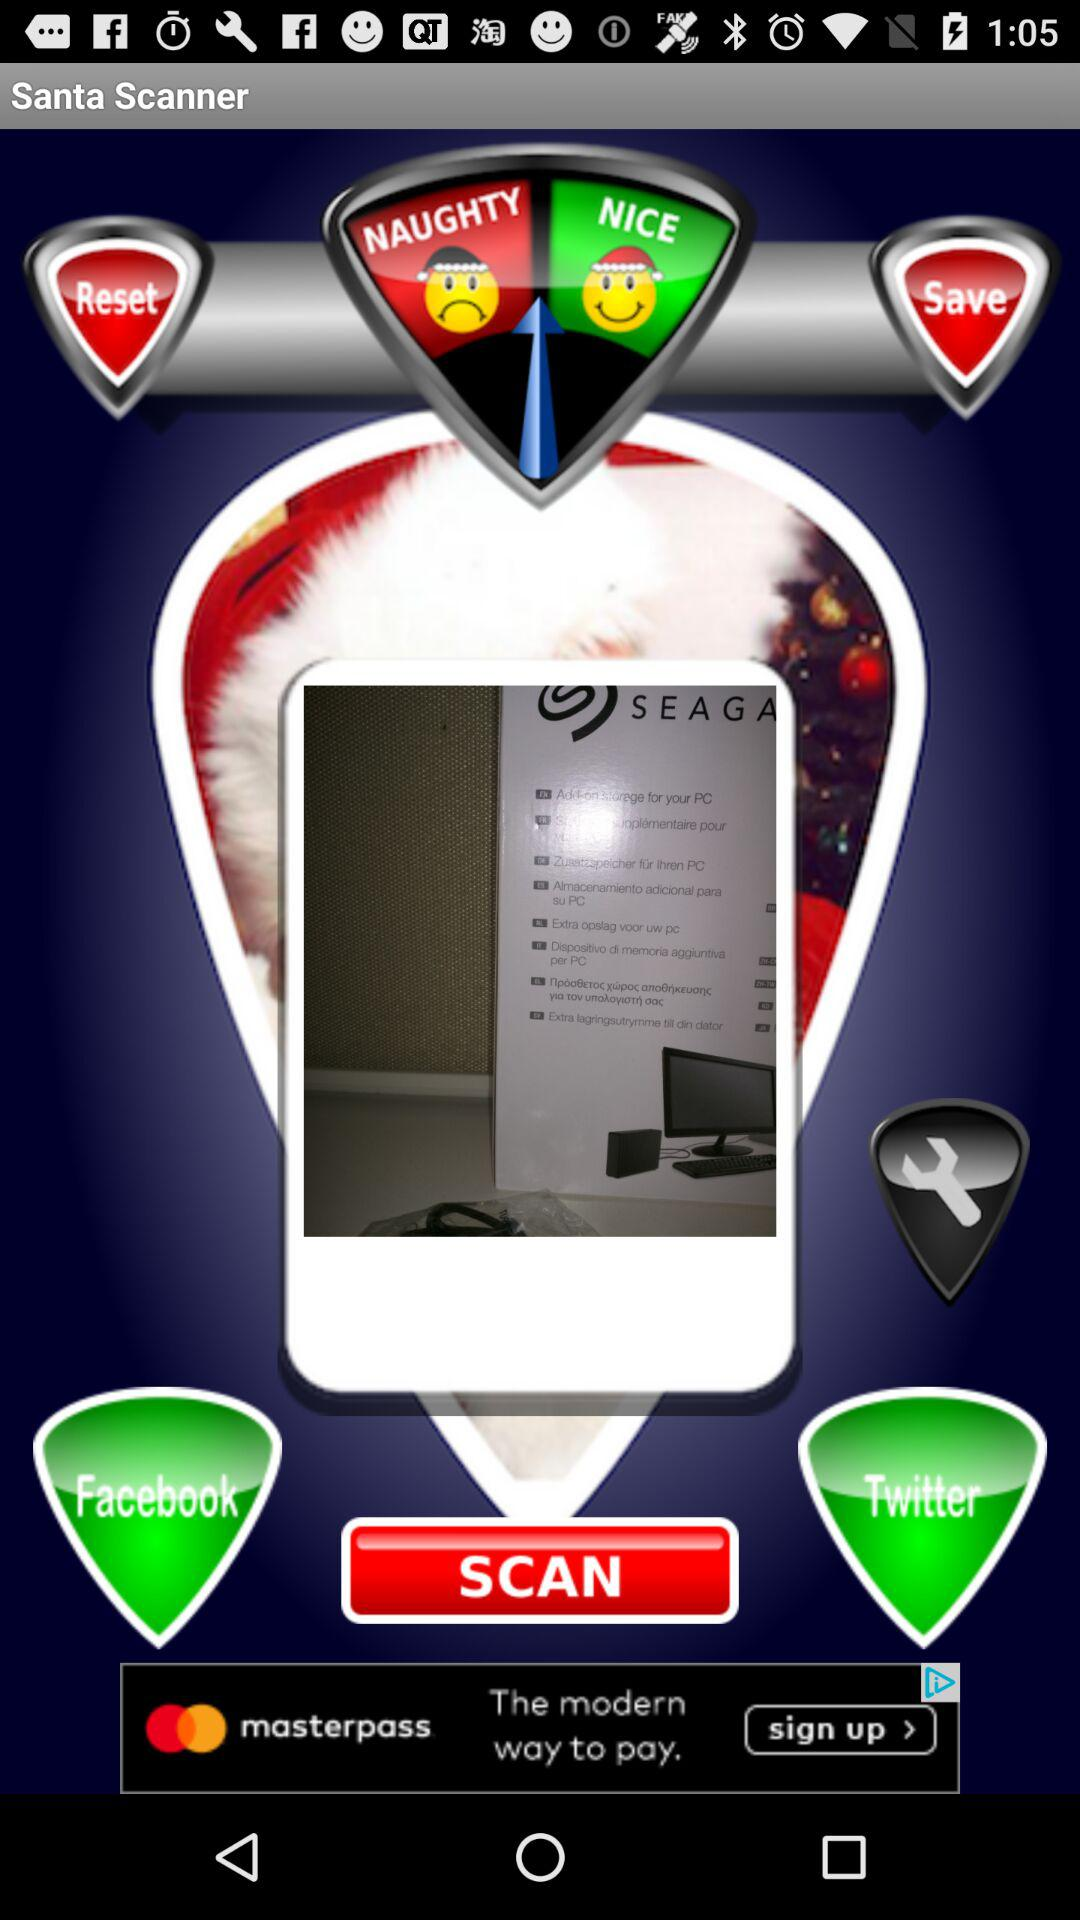Which accounts can be used for scanning? Accounts that can be used for scanning are "Facebook" and "Twitter". 